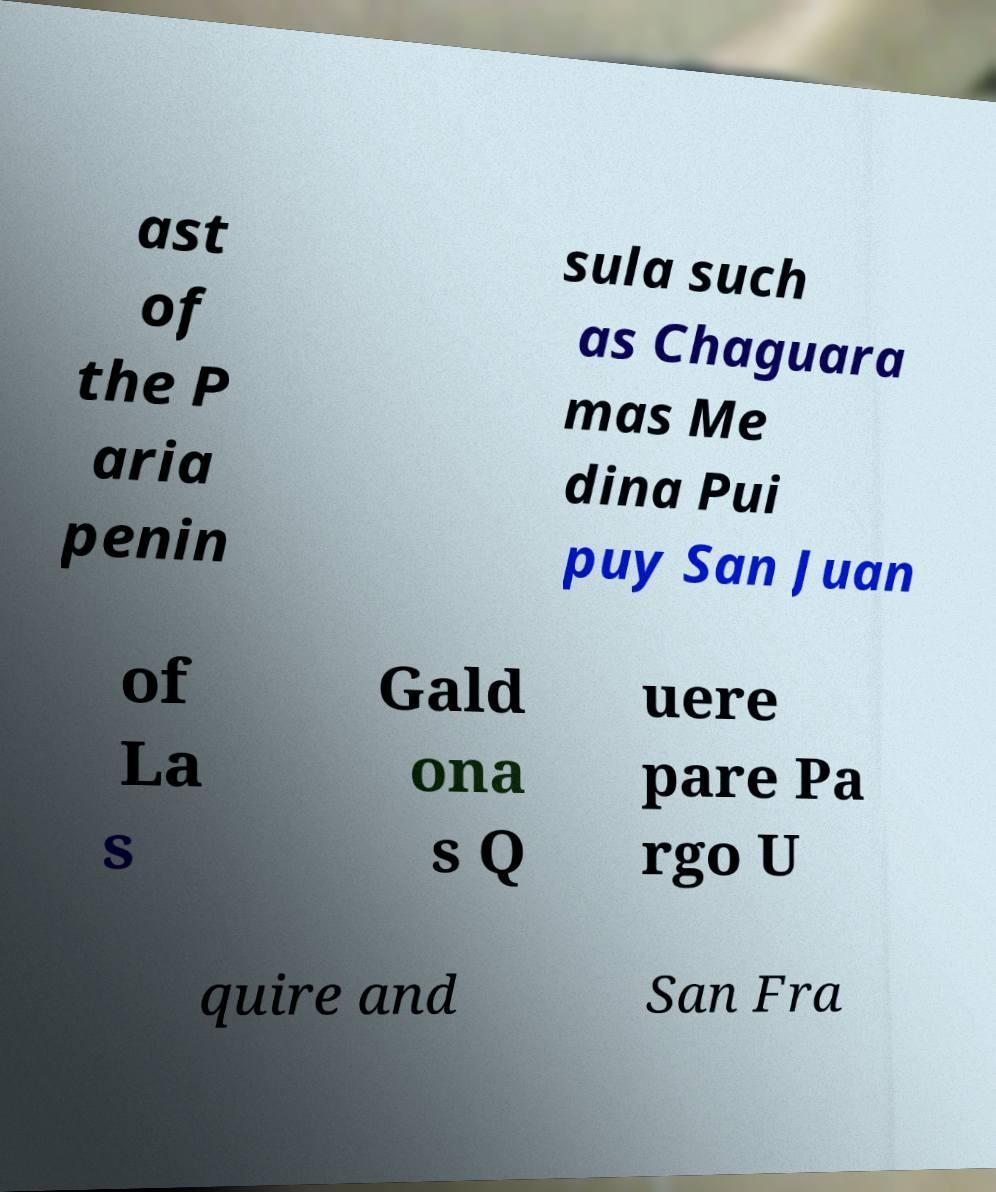Can you read and provide the text displayed in the image?This photo seems to have some interesting text. Can you extract and type it out for me? ast of the P aria penin sula such as Chaguara mas Me dina Pui puy San Juan of La s Gald ona s Q uere pare Pa rgo U quire and San Fra 